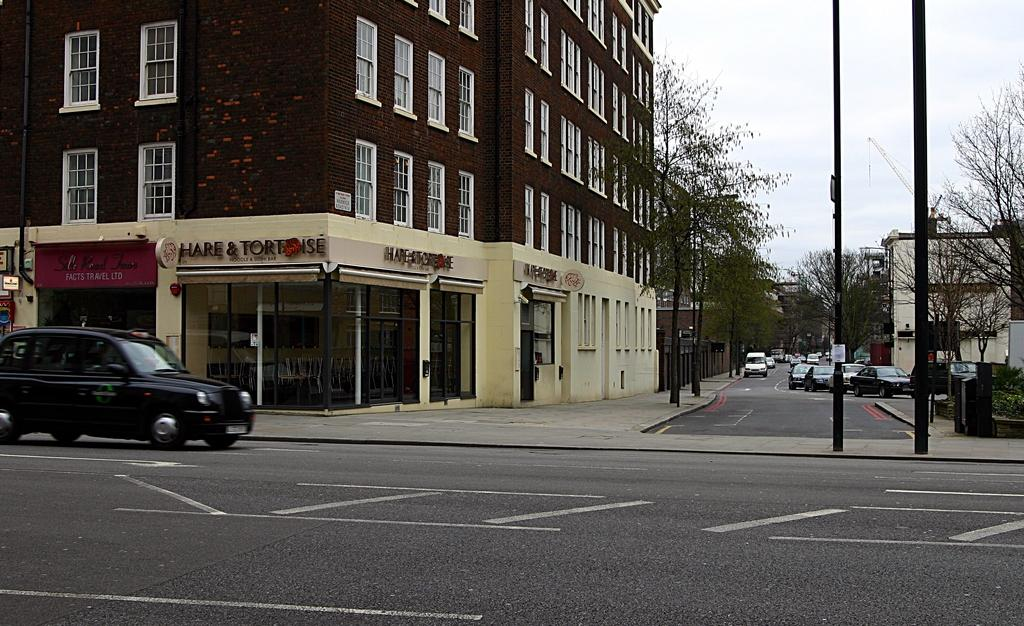<image>
Share a concise interpretation of the image provided. The outside of a corner restaurant that sells noodles and sushi 